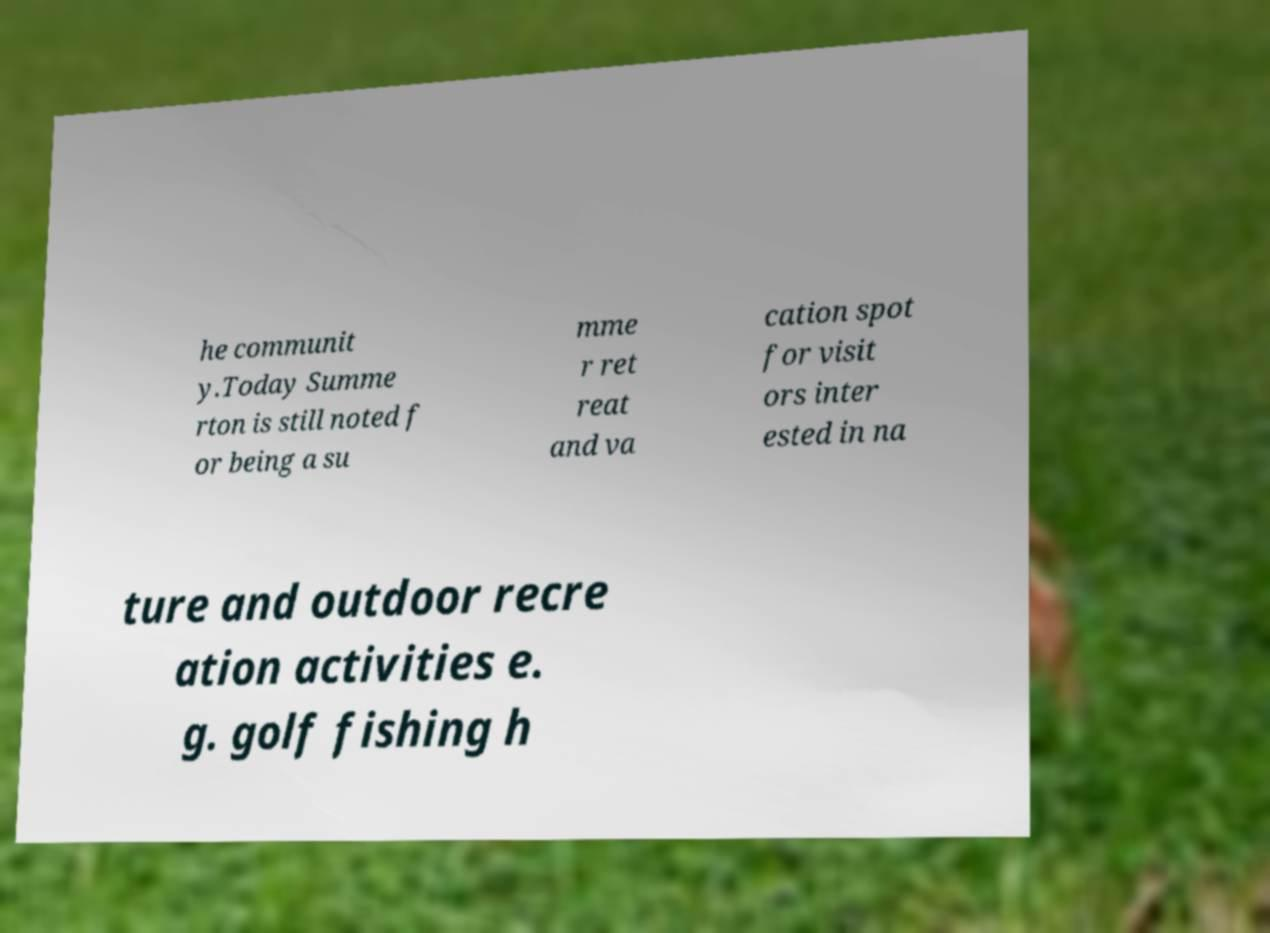What messages or text are displayed in this image? I need them in a readable, typed format. he communit y.Today Summe rton is still noted f or being a su mme r ret reat and va cation spot for visit ors inter ested in na ture and outdoor recre ation activities e. g. golf fishing h 